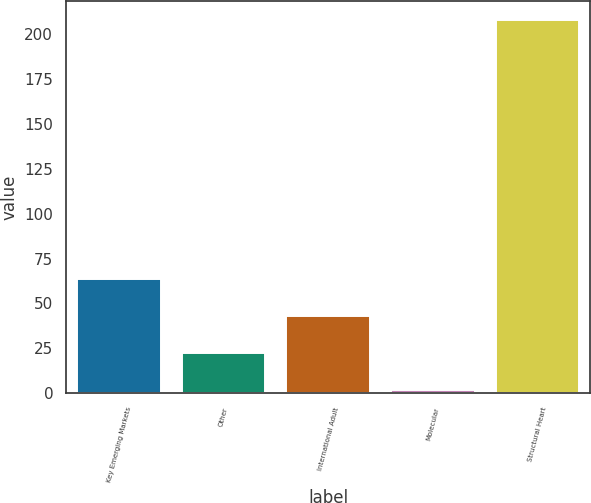Convert chart to OTSL. <chart><loc_0><loc_0><loc_500><loc_500><bar_chart><fcel>Key Emerging Markets<fcel>Other<fcel>International Adult<fcel>Molecular<fcel>Structural Heart<nl><fcel>63.8<fcel>22.6<fcel>43.2<fcel>2<fcel>208<nl></chart> 